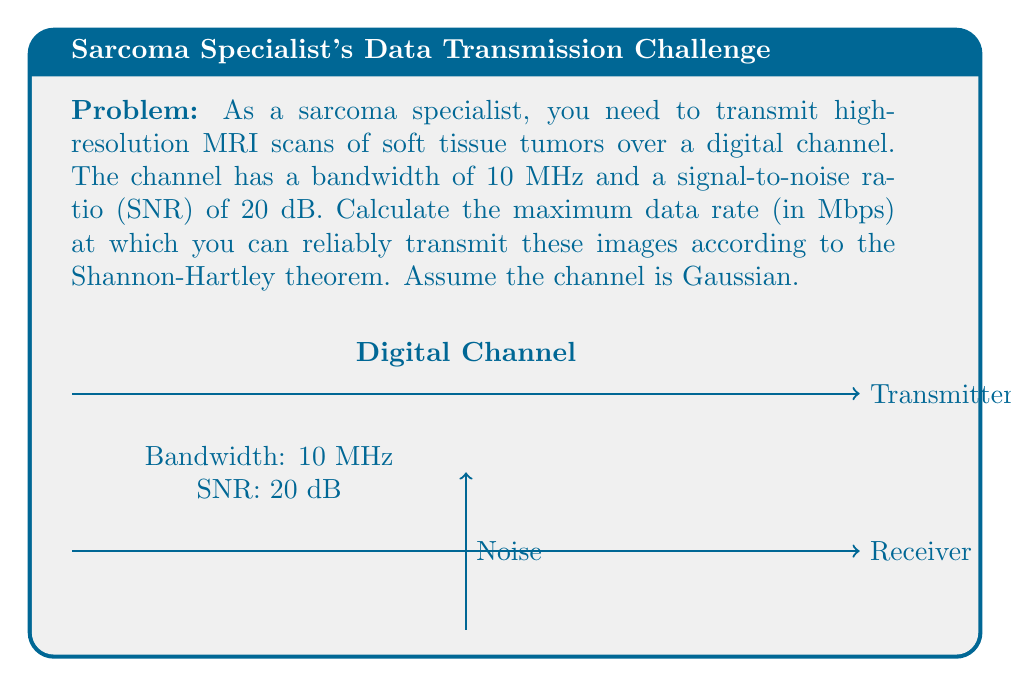Could you help me with this problem? To solve this problem, we'll use the Shannon-Hartley theorem, which gives the channel capacity for a Gaussian channel. The steps are as follows:

1) The Shannon-Hartley theorem states that the channel capacity $C$ is:

   $$C = B \log_2(1 + SNR)$$

   where $B$ is the bandwidth in Hz, and SNR is the signal-to-noise ratio.

2) We're given:
   - Bandwidth $B = 10$ MHz = $10 \times 10^6$ Hz
   - SNR = 20 dB

3) We need to convert the SNR from dB to a linear scale:
   $$SNR_{linear} = 10^{SNR_{dB}/10} = 10^{20/10} = 100$$

4) Now we can plug these values into the Shannon-Hartley theorem:

   $$C = (10 \times 10^6) \log_2(1 + 100)$$

5) Simplify:
   $$C = (10 \times 10^6) \log_2(101)$$

6) Calculate $\log_2(101)$:
   $$\log_2(101) \approx 6.6582$$

7) Multiply:
   $$C \approx (10 \times 10^6) \times 6.6582 = 66.582 \times 10^6 \text{ bits/second}$$

8) Convert to Mbps:
   $$C \approx 66.582 \text{ Mbps}$$

Therefore, the maximum data rate at which you can reliably transmit the MRI scans is approximately 66.582 Mbps.
Answer: 66.582 Mbps 